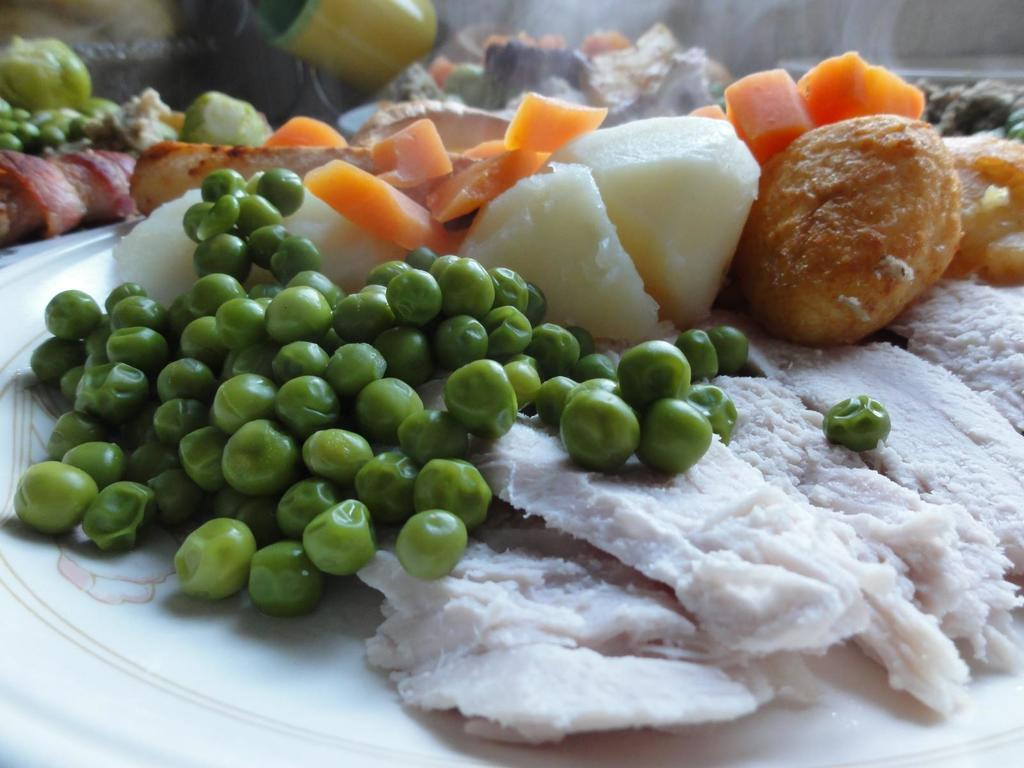What is the main object in the center of the image? There is a plate in the center of the image. What types of vegetables are on the plate? The plate contains peas and carrots. What other food items are on the plate? The plate contains other food items besides peas and carrots. How many giants are sitting on the plate in the image? There are no giants present in the image; the plate contains food items. Can you see a kitty playing with the peas on the plate? There is no kitty present in the image; the plate contains food items only. 